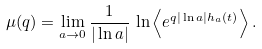Convert formula to latex. <formula><loc_0><loc_0><loc_500><loc_500>\mu ( q ) = \lim _ { a \rightarrow 0 } \frac { 1 } { | \ln a | } \, \ln \left < e ^ { q | \ln a | h _ { a } ( t ) } \right > .</formula> 